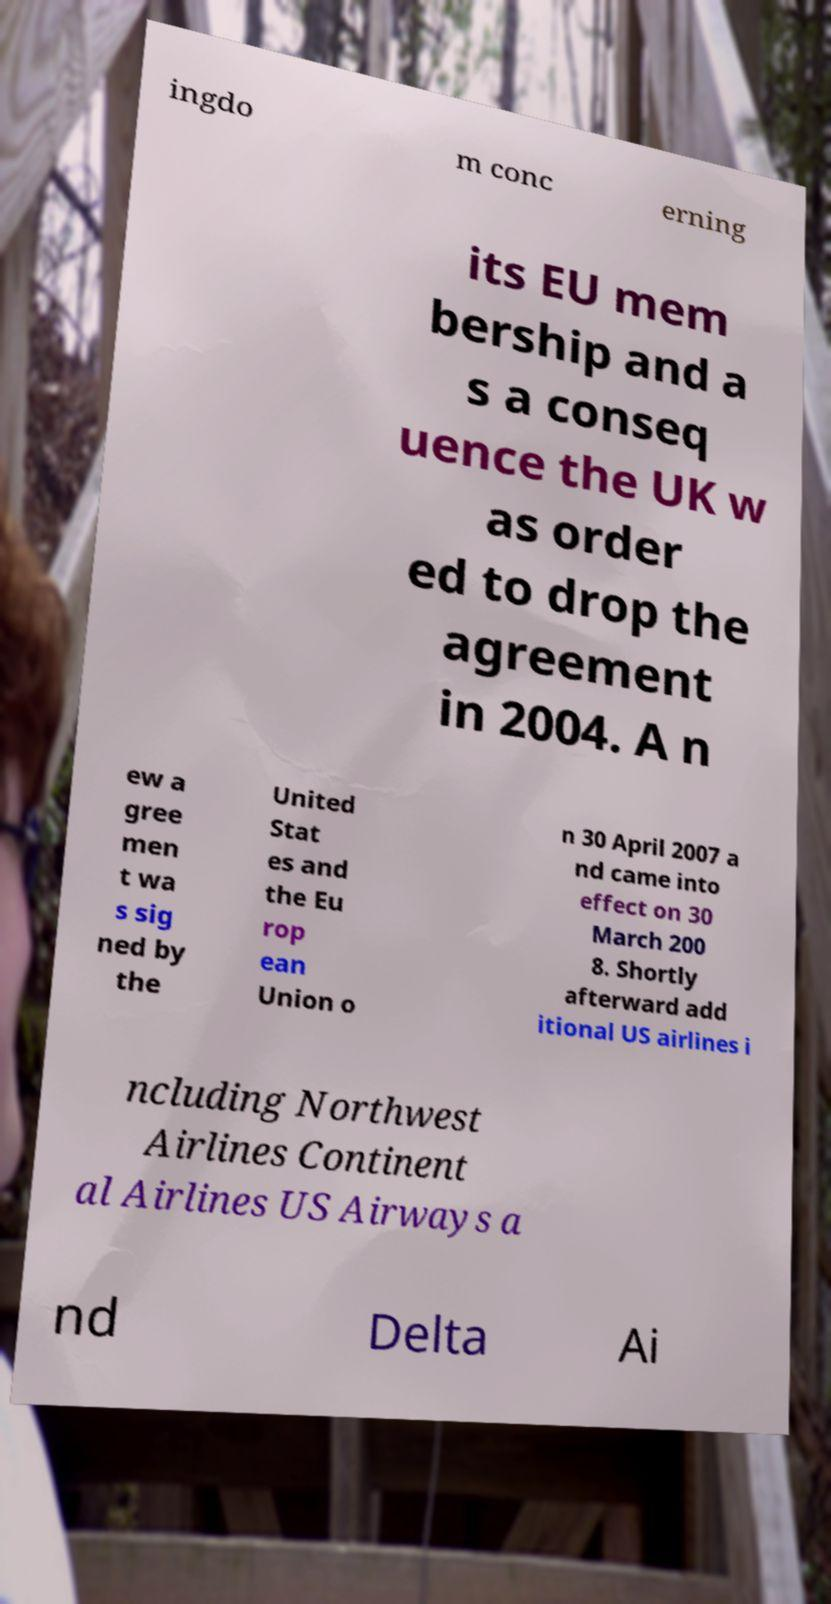Could you extract and type out the text from this image? ingdo m conc erning its EU mem bership and a s a conseq uence the UK w as order ed to drop the agreement in 2004. A n ew a gree men t wa s sig ned by the United Stat es and the Eu rop ean Union o n 30 April 2007 a nd came into effect on 30 March 200 8. Shortly afterward add itional US airlines i ncluding Northwest Airlines Continent al Airlines US Airways a nd Delta Ai 